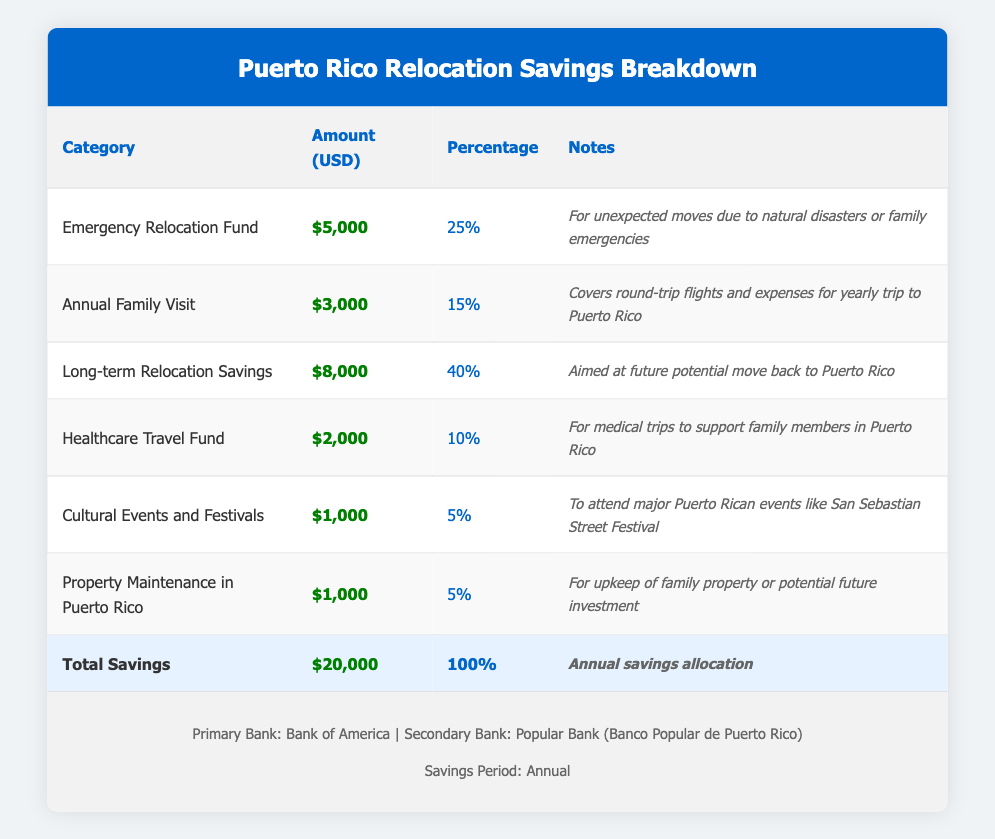What is the amount allocated for the Emergency Relocation Fund? The table lists the Emergency Relocation Fund under the category column, and the corresponding amount for this fund is $5,000.
Answer: $5,000 What percentage of total savings is set aside for Healthcare Travel Fund? The Healthcare Travel Fund is listed with a percentage value in the table. It shows 10% of the total savings is allocated for this fund.
Answer: 10% How much total savings is allocated for yearly visits to Puerto Rico? From the table, two categories are related to visits: the Annual Family Visit ($3,000) and Healthcare Travel Fund ($2,000). Adding these amounts (3,000 + 2,000) gives $5,000 total for visits to Puerto Rico.
Answer: $5,000 Is the Long-term Relocation Savings fund larger than the combined amounts of the Cultural Events and Festivals and Property Maintenance in Puerto Rico? The Long-term Relocation Savings is $8,000, while the Cultural Events ($1,000) and Property Maintenance ($1,000) together equal $2,000. Since $8,000 is greater than $2,000, the statement is true.
Answer: Yes What is the total amount allocated for cultural-related expenses? The Cultural Events and Festivals category is $1,000, and there is no other related category that specifies cultural expenses in the table, so the total remains $1,000.
Answer: $1,000 If you combine the Emergency Relocation Fund and the Long-term Relocation Savings, what will the new total amount be? The Emergency Relocation Fund is $5,000 and the Long-term Relocation Savings is $8,000. Adding these two amounts gives (5,000 + 8,000) = $13,000.
Answer: $13,000 What percentage of the total savings is allocated to the Annual Family Visit fund compared to the sum of Cultural Events and Property Maintenance? The Annual Family Visit fund is 15% of the total savings. The Cultural Events and Property Maintenance combined total $2,000, which is 10% of the total savings. Since 15% is greater than 10%, the answer is yes.
Answer: Yes What is the average allocation of savings across the categories listed in the table? There are six savings categories provided in the table. The total savings amount is $20,000. To find the average, divide the total (20,000) by the number of categories (6): 20,000 / 6 = approximately $3,333.33.
Answer: $3,333.33 How much more is allocated for Long-term Relocation Savings than for the Annual Family Visit? Long-term Relocation Savings amount to $8,000, while the Annual Family Visit is $3,000. The difference is calculated by subtracting the two amounts (8,000 - 3,000) = $5,000.
Answer: $5,000 